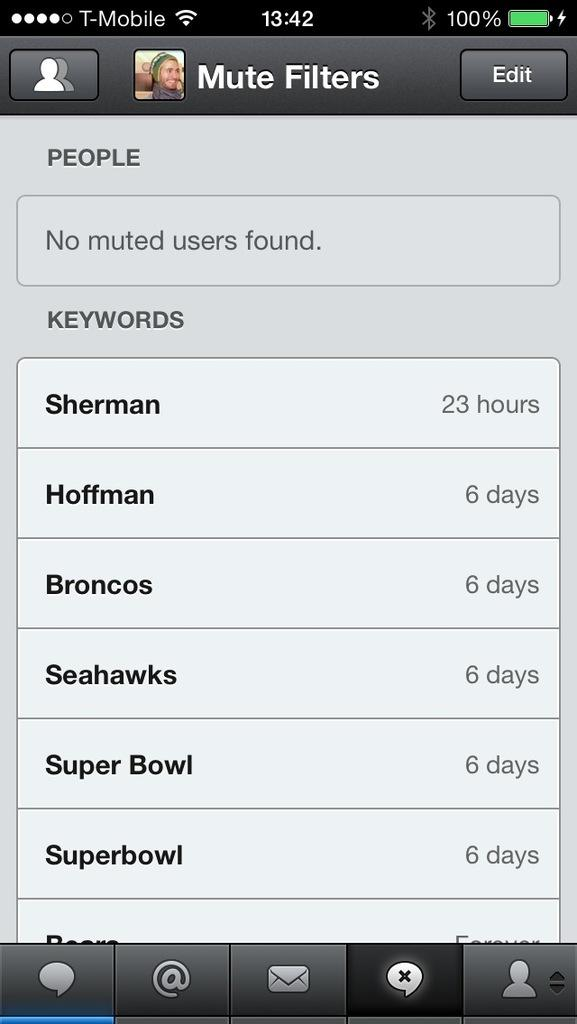Provide a one-sentence caption for the provided image. A phone page with the keywords of Sherman, Hoffman, Broncos, Seahawks, Super Bowl, Superbowl. 